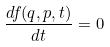Convert formula to latex. <formula><loc_0><loc_0><loc_500><loc_500>\frac { d f ( q , p , t ) } { d t } = 0</formula> 